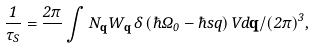Convert formula to latex. <formula><loc_0><loc_0><loc_500><loc_500>\frac { 1 } { \tau _ { S } } = \frac { 2 \pi } { } \int N _ { \mathbf q } W _ { \mathbf q } \, \delta \left ( \hbar { \Omega } _ { 0 } - \hbar { s } q \right ) { V d \mathbf q } / { \left ( 2 \pi \right ) ^ { 3 } } ,</formula> 